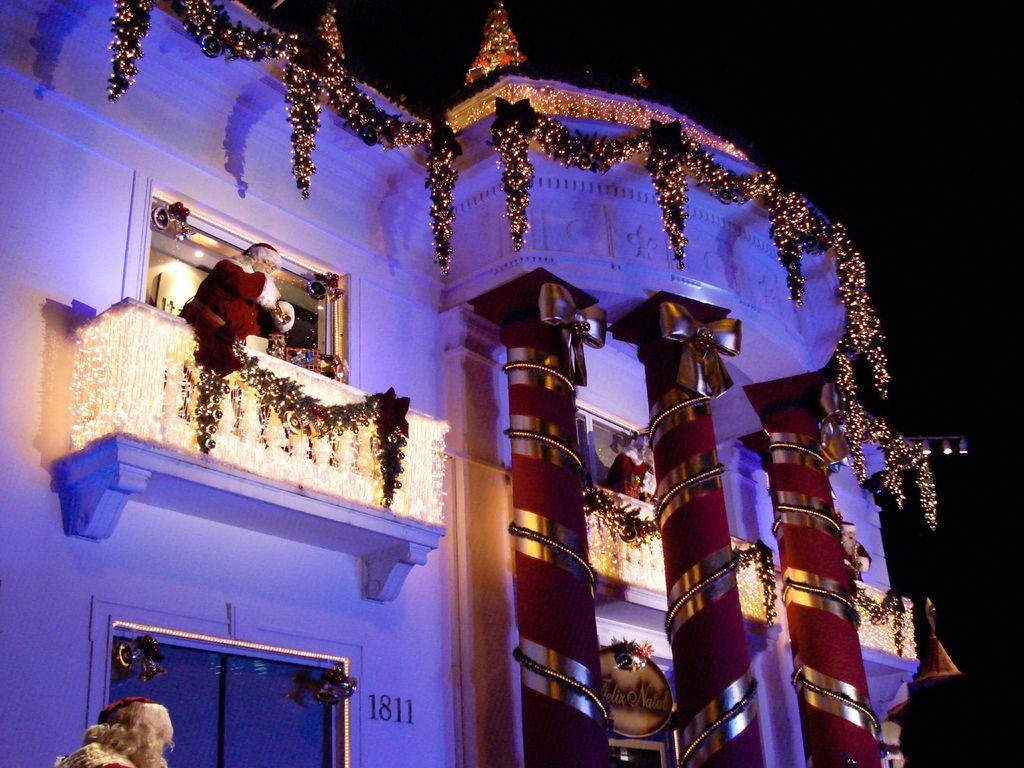Can you describe this image briefly? This picture is taken in the dark where we can see the pillars, decorative items, Xmas tree, LED lights, Santa Claus, board, building and the dark sky in the background. 